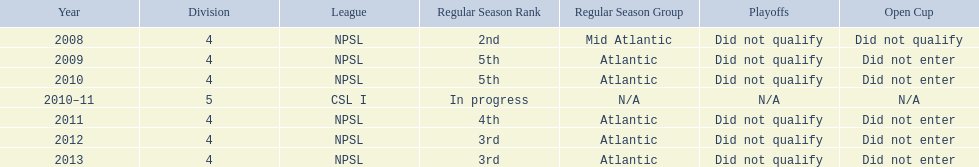What are the names of the leagues? NPSL, CSL I. Which league other than npsl did ny soccer team play under? CSL I. 